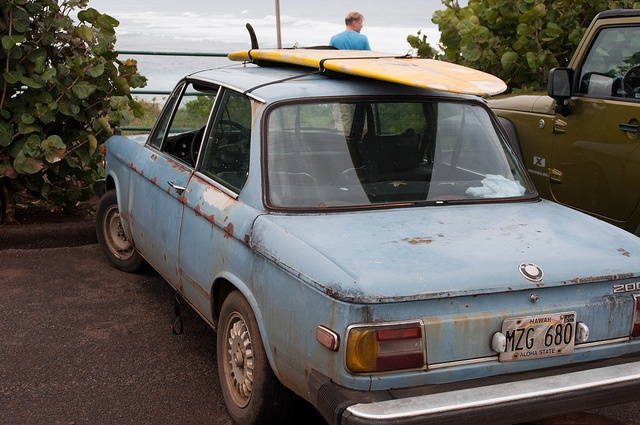Describe the objects in this image and their specific colors. I can see car in black, gray, and darkgray tones, car in black, gray, and olive tones, surfboard in black, lightgray, tan, and orange tones, and people in black, gray, darkgray, lightblue, and brown tones in this image. 